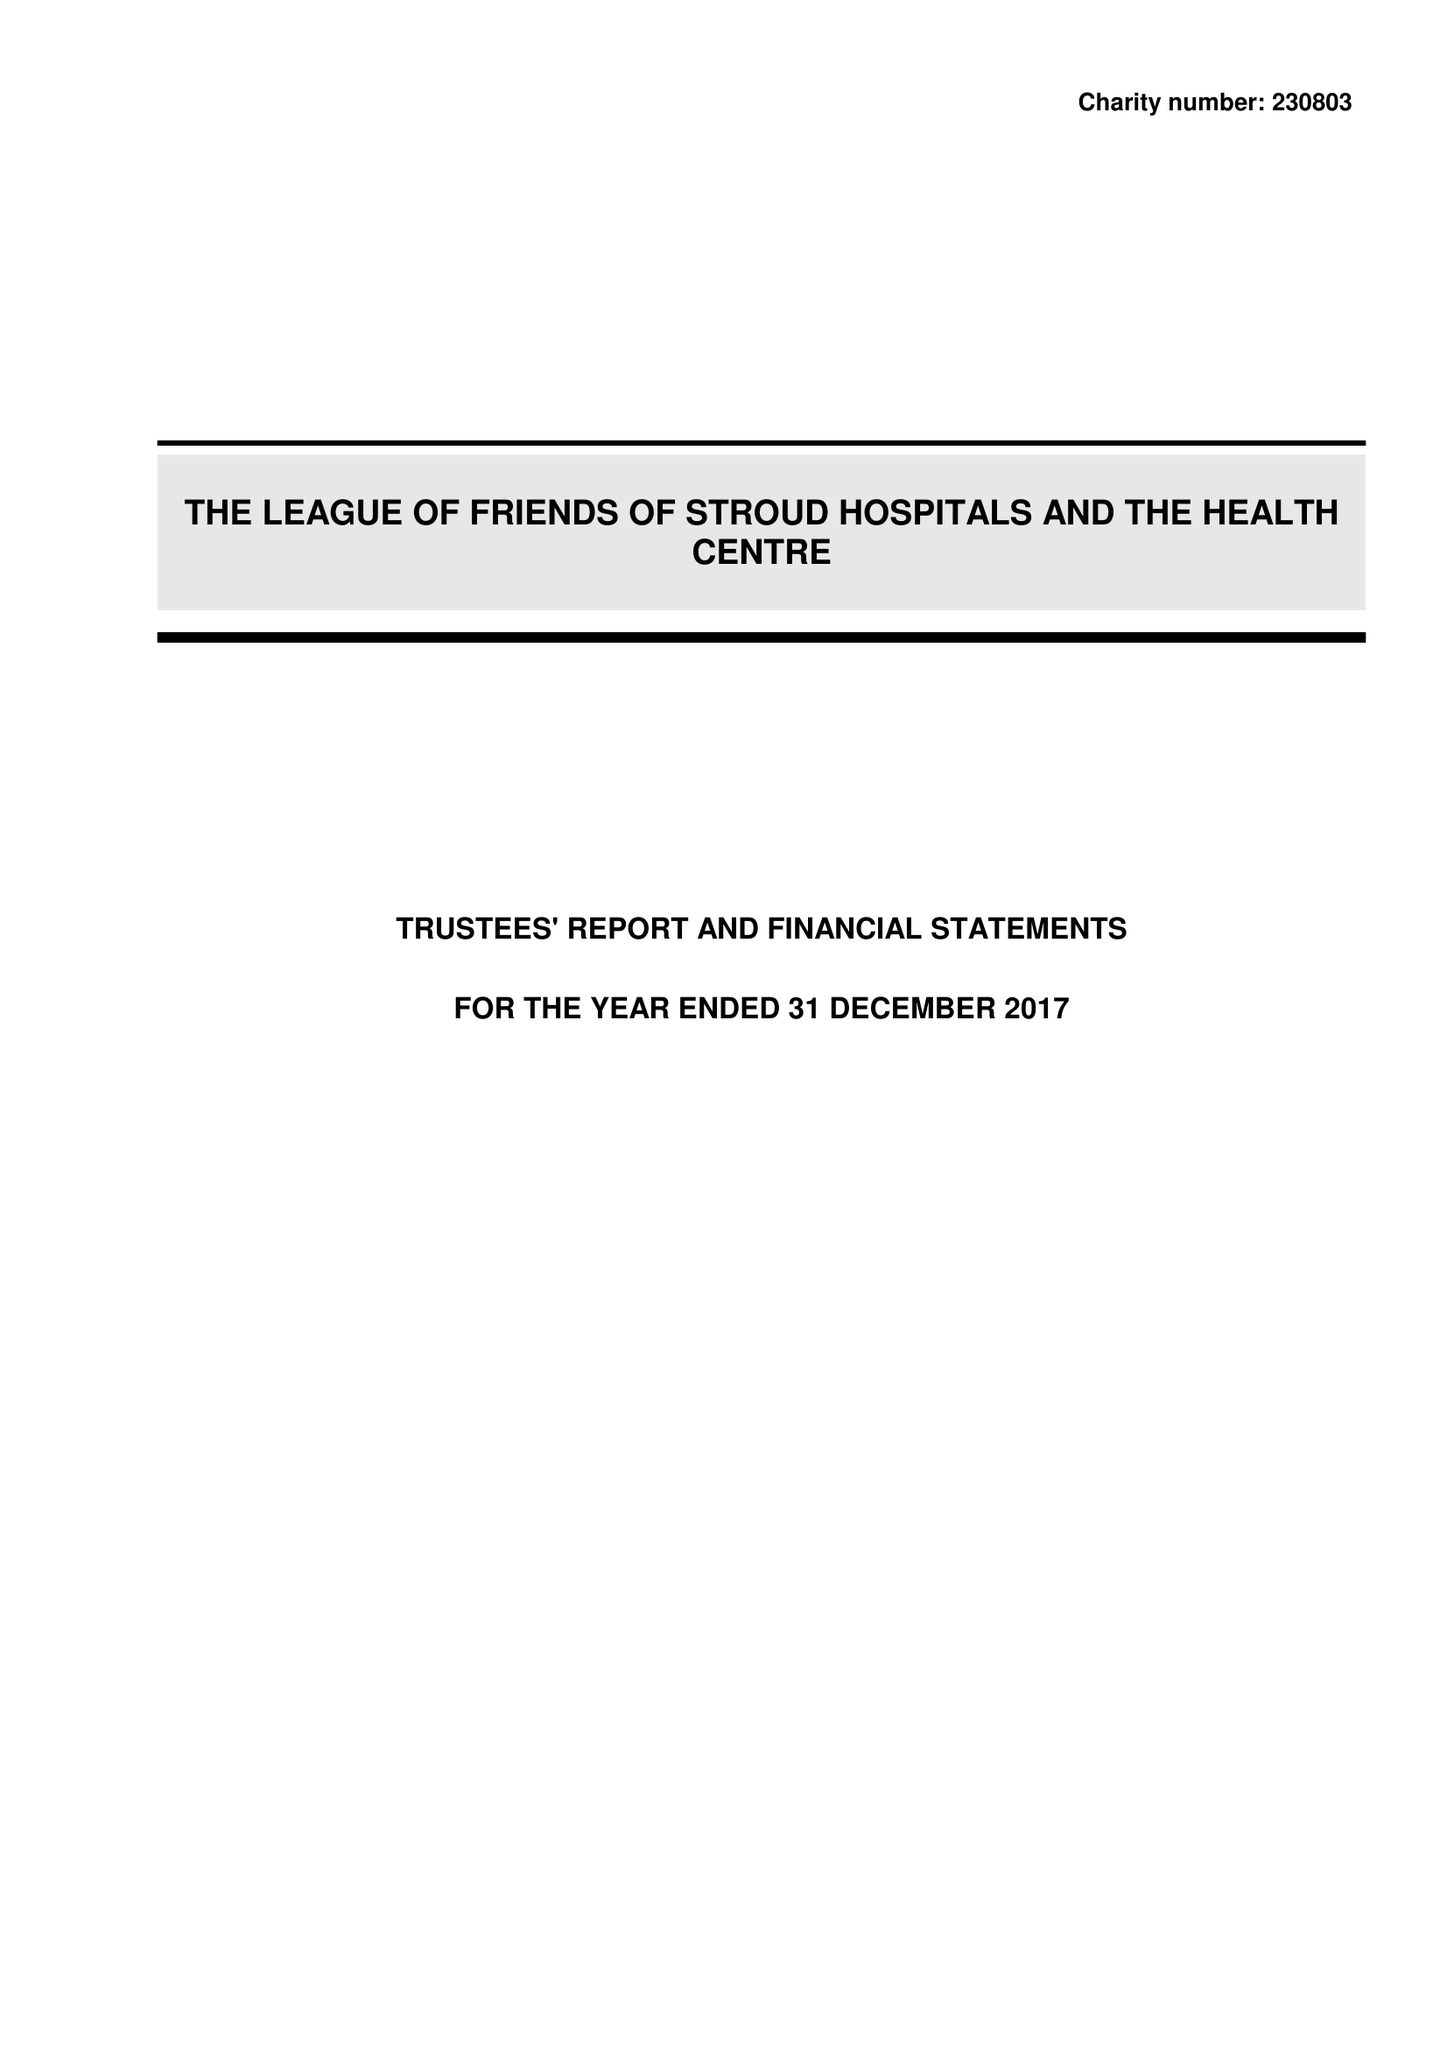What is the value for the income_annually_in_british_pounds?
Answer the question using a single word or phrase. 337757.00 